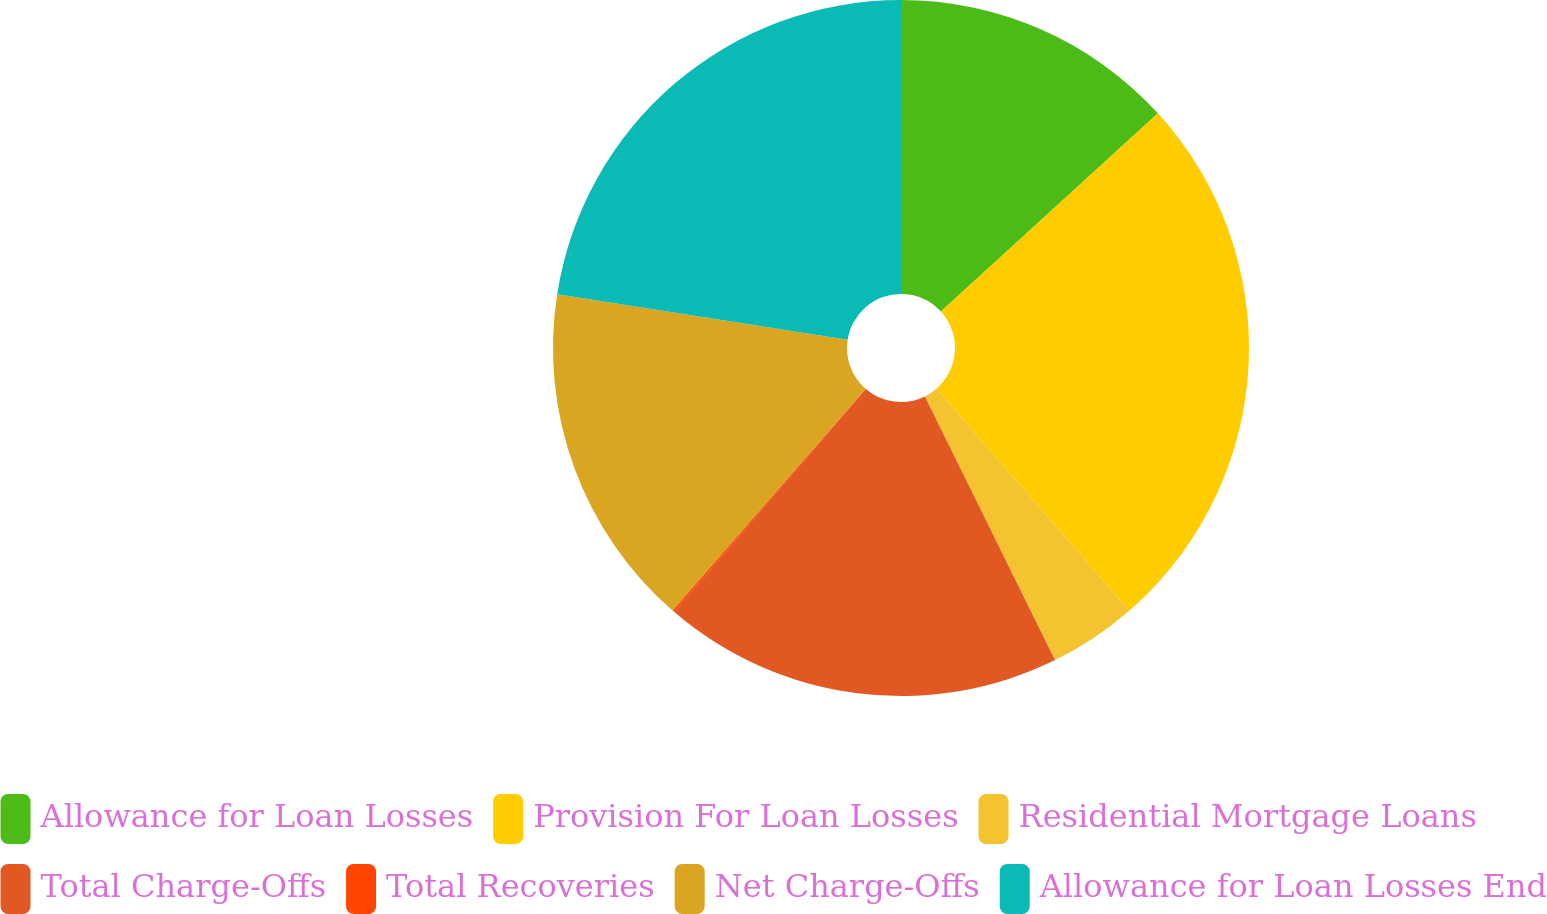Convert chart to OTSL. <chart><loc_0><loc_0><loc_500><loc_500><pie_chart><fcel>Allowance for Loan Losses<fcel>Provision For Loan Losses<fcel>Residential Mortgage Loans<fcel>Total Charge-Offs<fcel>Total Recoveries<fcel>Net Charge-Offs<fcel>Allowance for Loan Losses End<nl><fcel>13.22%<fcel>25.39%<fcel>4.09%<fcel>18.6%<fcel>0.09%<fcel>16.07%<fcel>22.53%<nl></chart> 